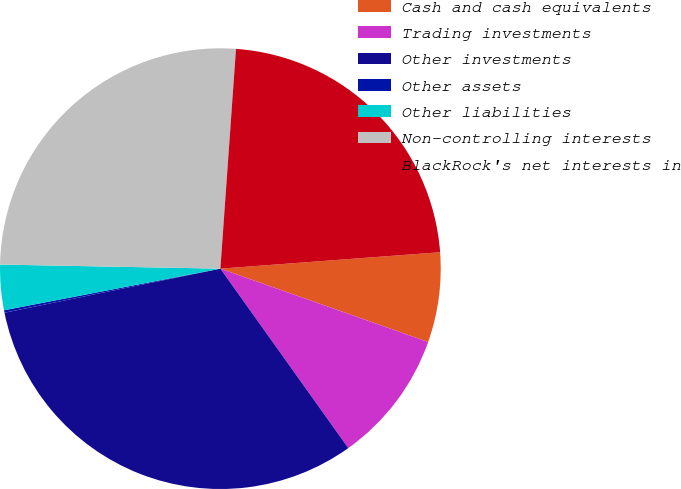Convert chart. <chart><loc_0><loc_0><loc_500><loc_500><pie_chart><fcel>Cash and cash equivalents<fcel>Trading investments<fcel>Other investments<fcel>Other assets<fcel>Other liabilities<fcel>Non-controlling interests<fcel>BlackRock's net interests in<nl><fcel>6.59%<fcel>9.74%<fcel>31.65%<fcel>0.18%<fcel>3.32%<fcel>25.83%<fcel>22.68%<nl></chart> 